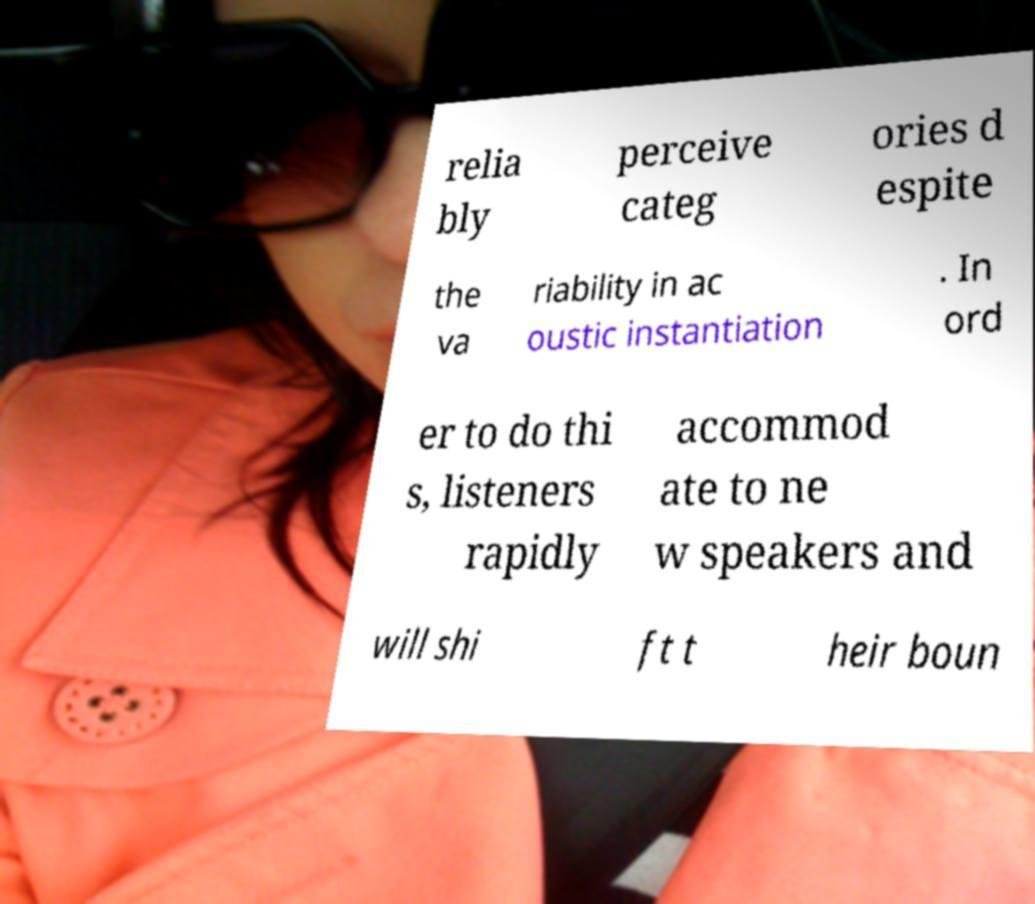I need the written content from this picture converted into text. Can you do that? relia bly perceive categ ories d espite the va riability in ac oustic instantiation . In ord er to do thi s, listeners rapidly accommod ate to ne w speakers and will shi ft t heir boun 